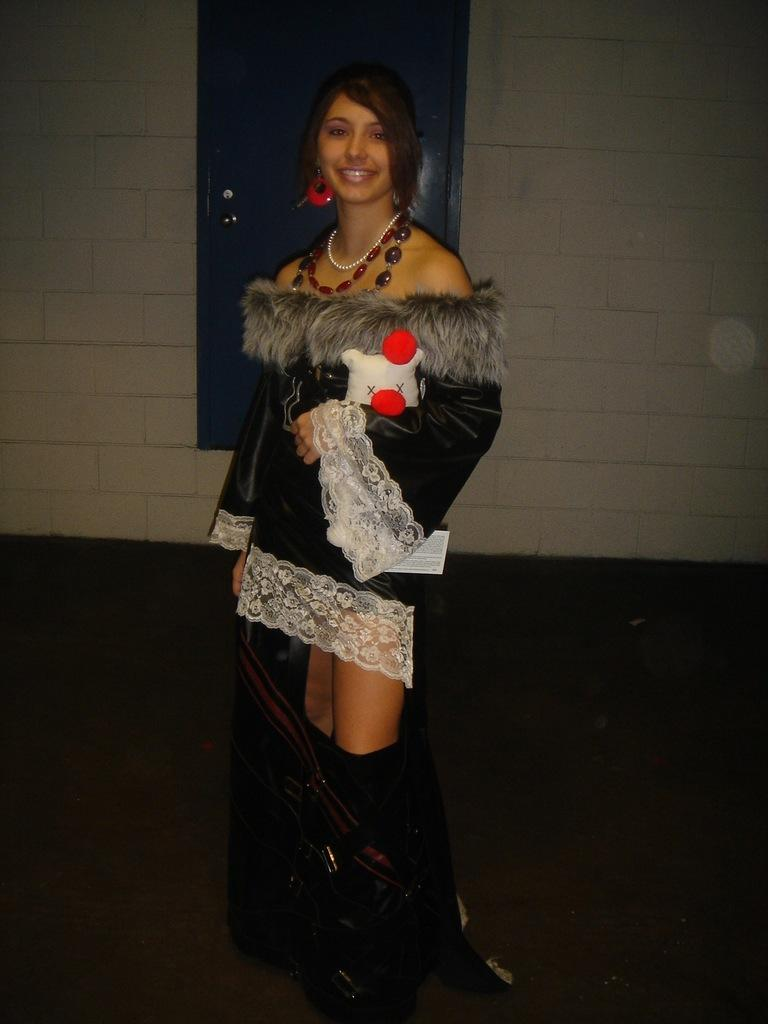Who is present in the image? There is a woman in the image. What is the woman doing in the image? The woman is standing in the image. What is the woman wearing in the image? The woman is wearing a jacket in the image. What can be seen on the wall in the image? There is a door on the wall in the image. How does the quartz react during the earthquake in the image? There is no quartz or earthquake present in the image. What type of group is shown gathering around the woman in the image? There is no group present in the image; the woman is standing alone. 